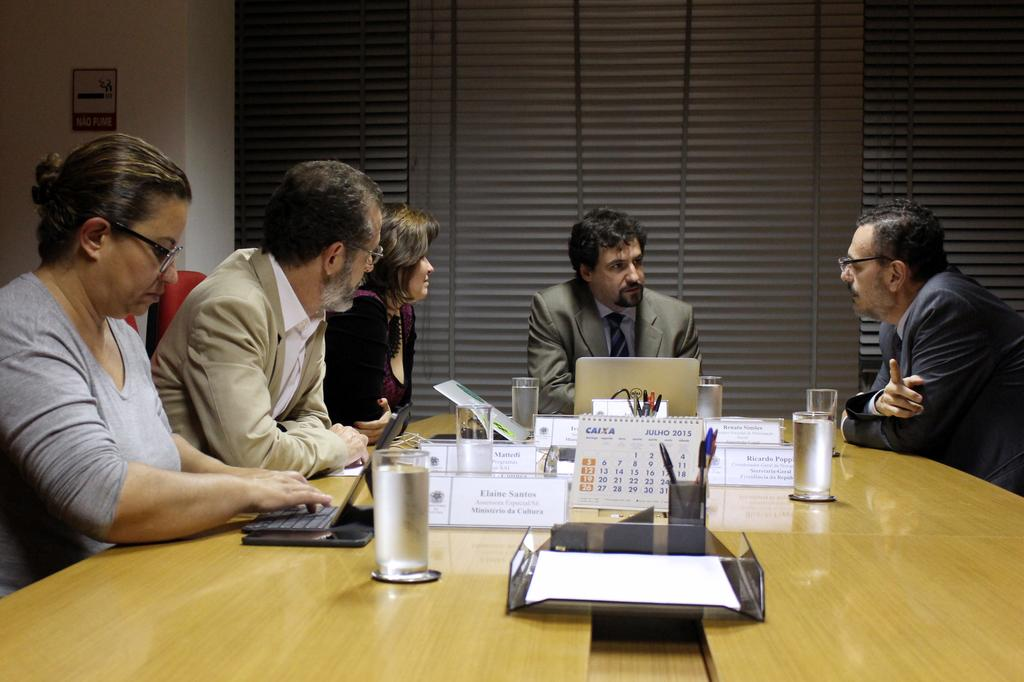What type of structure can be seen in the image? There is a wall in the image. What is hanging on the wall? There is a photo frame in the image. What are the people in the image doing? There are people sitting on chairs in the image. What is on the table in the image? There are glasses, posters, and a laptop on the table. How many girls are present in the image? There is no girl present in the image; only people sitting on chairs are visible. What type of badge can be seen on the laptop? There is no badge present on the laptop or any other item in the image. 